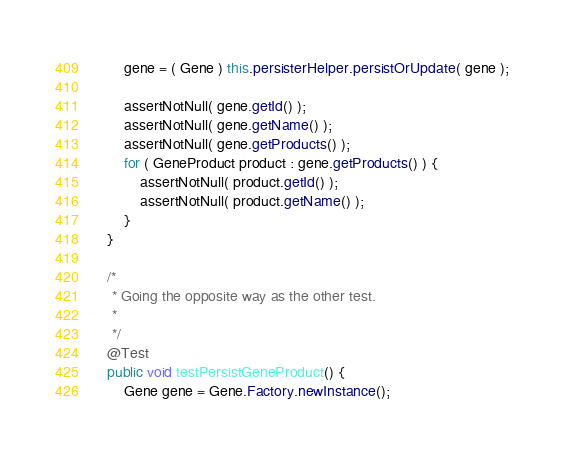Convert code to text. <code><loc_0><loc_0><loc_500><loc_500><_Java_>        gene = ( Gene ) this.persisterHelper.persistOrUpdate( gene );

        assertNotNull( gene.getId() );
        assertNotNull( gene.getName() );
        assertNotNull( gene.getProducts() );
        for ( GeneProduct product : gene.getProducts() ) {
            assertNotNull( product.getId() );
            assertNotNull( product.getName() );
        }
    }

    /*
     * Going the opposite way as the other test.
     *
     */
    @Test
    public void testPersistGeneProduct() {
        Gene gene = Gene.Factory.newInstance();</code> 